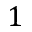<formula> <loc_0><loc_0><loc_500><loc_500>1</formula> 